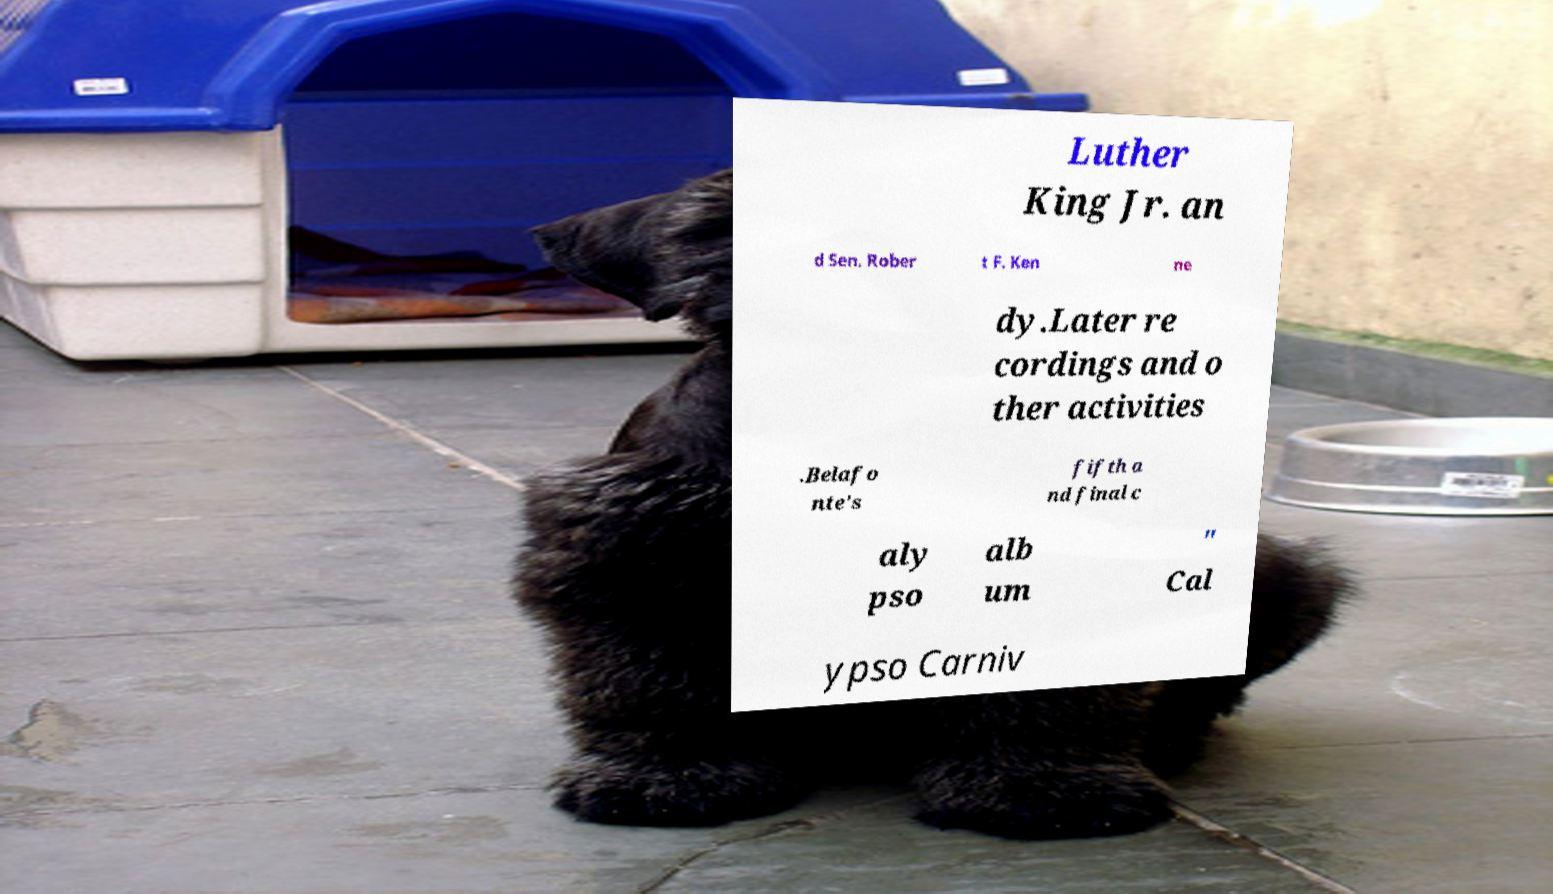Could you assist in decoding the text presented in this image and type it out clearly? Luther King Jr. an d Sen. Rober t F. Ken ne dy.Later re cordings and o ther activities .Belafo nte's fifth a nd final c aly pso alb um " Cal ypso Carniv 